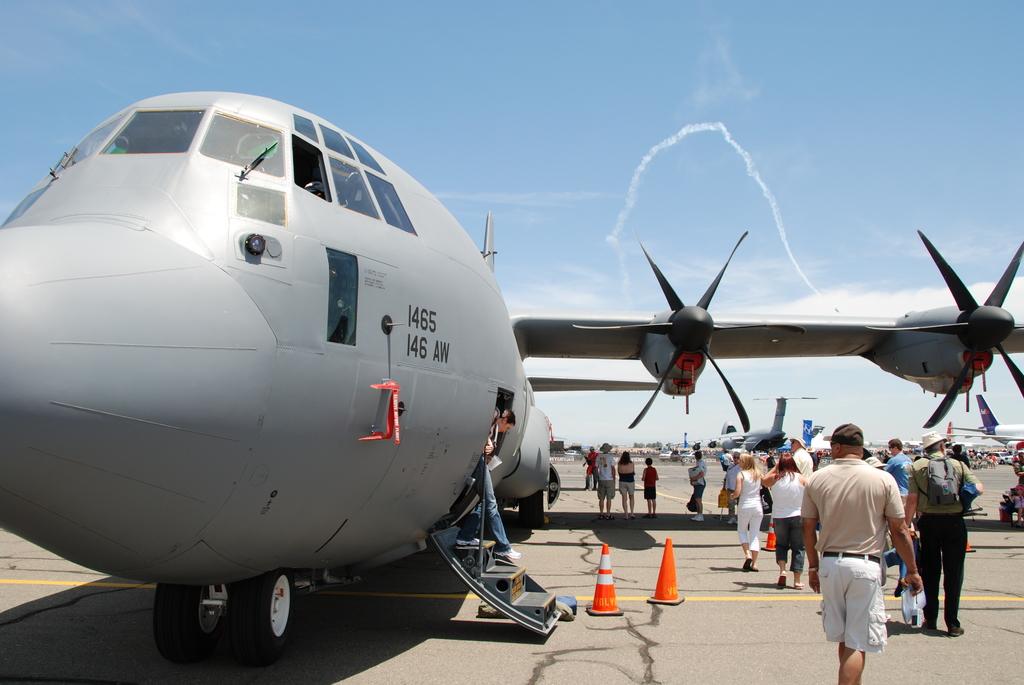What are the letters on the side of the plane?
Your answer should be compact. Aw. What number is this?
Ensure brevity in your answer.  1465. 